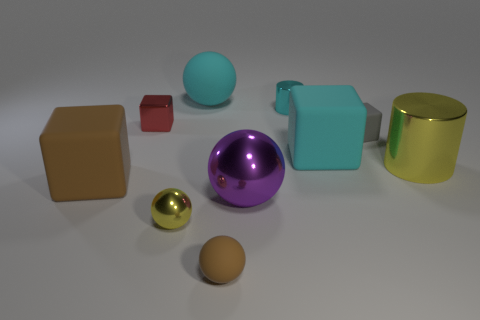Subtract all cylinders. How many objects are left? 8 Subtract 4 balls. How many balls are left? 0 Subtract all gray spheres. Subtract all yellow cylinders. How many spheres are left? 4 Subtract all green cylinders. How many yellow balls are left? 1 Subtract all spheres. Subtract all small matte things. How many objects are left? 4 Add 4 tiny gray cubes. How many tiny gray cubes are left? 5 Add 4 tiny yellow rubber cubes. How many tiny yellow rubber cubes exist? 4 Subtract all gray blocks. How many blocks are left? 3 Subtract all purple shiny spheres. How many spheres are left? 3 Subtract 1 purple balls. How many objects are left? 9 